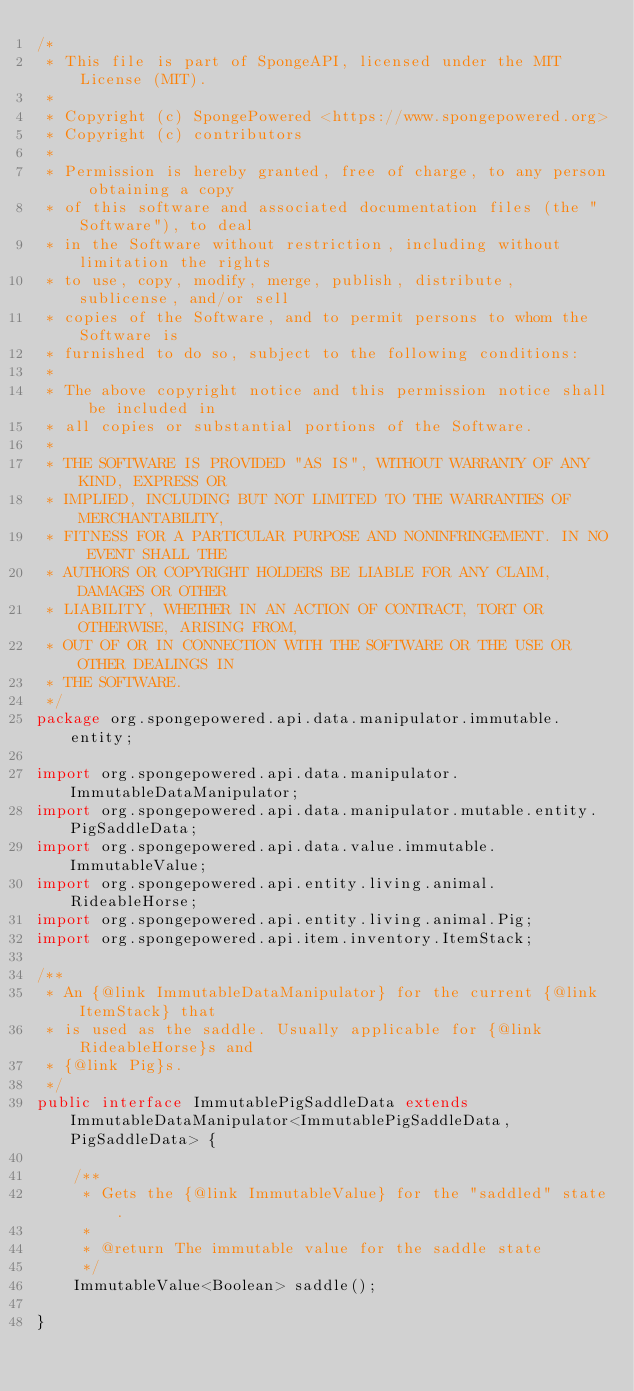<code> <loc_0><loc_0><loc_500><loc_500><_Java_>/*
 * This file is part of SpongeAPI, licensed under the MIT License (MIT).
 *
 * Copyright (c) SpongePowered <https://www.spongepowered.org>
 * Copyright (c) contributors
 *
 * Permission is hereby granted, free of charge, to any person obtaining a copy
 * of this software and associated documentation files (the "Software"), to deal
 * in the Software without restriction, including without limitation the rights
 * to use, copy, modify, merge, publish, distribute, sublicense, and/or sell
 * copies of the Software, and to permit persons to whom the Software is
 * furnished to do so, subject to the following conditions:
 *
 * The above copyright notice and this permission notice shall be included in
 * all copies or substantial portions of the Software.
 *
 * THE SOFTWARE IS PROVIDED "AS IS", WITHOUT WARRANTY OF ANY KIND, EXPRESS OR
 * IMPLIED, INCLUDING BUT NOT LIMITED TO THE WARRANTIES OF MERCHANTABILITY,
 * FITNESS FOR A PARTICULAR PURPOSE AND NONINFRINGEMENT. IN NO EVENT SHALL THE
 * AUTHORS OR COPYRIGHT HOLDERS BE LIABLE FOR ANY CLAIM, DAMAGES OR OTHER
 * LIABILITY, WHETHER IN AN ACTION OF CONTRACT, TORT OR OTHERWISE, ARISING FROM,
 * OUT OF OR IN CONNECTION WITH THE SOFTWARE OR THE USE OR OTHER DEALINGS IN
 * THE SOFTWARE.
 */
package org.spongepowered.api.data.manipulator.immutable.entity;

import org.spongepowered.api.data.manipulator.ImmutableDataManipulator;
import org.spongepowered.api.data.manipulator.mutable.entity.PigSaddleData;
import org.spongepowered.api.data.value.immutable.ImmutableValue;
import org.spongepowered.api.entity.living.animal.RideableHorse;
import org.spongepowered.api.entity.living.animal.Pig;
import org.spongepowered.api.item.inventory.ItemStack;

/**
 * An {@link ImmutableDataManipulator} for the current {@link ItemStack} that
 * is used as the saddle. Usually applicable for {@link RideableHorse}s and
 * {@link Pig}s.
 */
public interface ImmutablePigSaddleData extends ImmutableDataManipulator<ImmutablePigSaddleData, PigSaddleData> {

    /**
     * Gets the {@link ImmutableValue} for the "saddled" state.
     *
     * @return The immutable value for the saddle state
     */
    ImmutableValue<Boolean> saddle();

}
</code> 